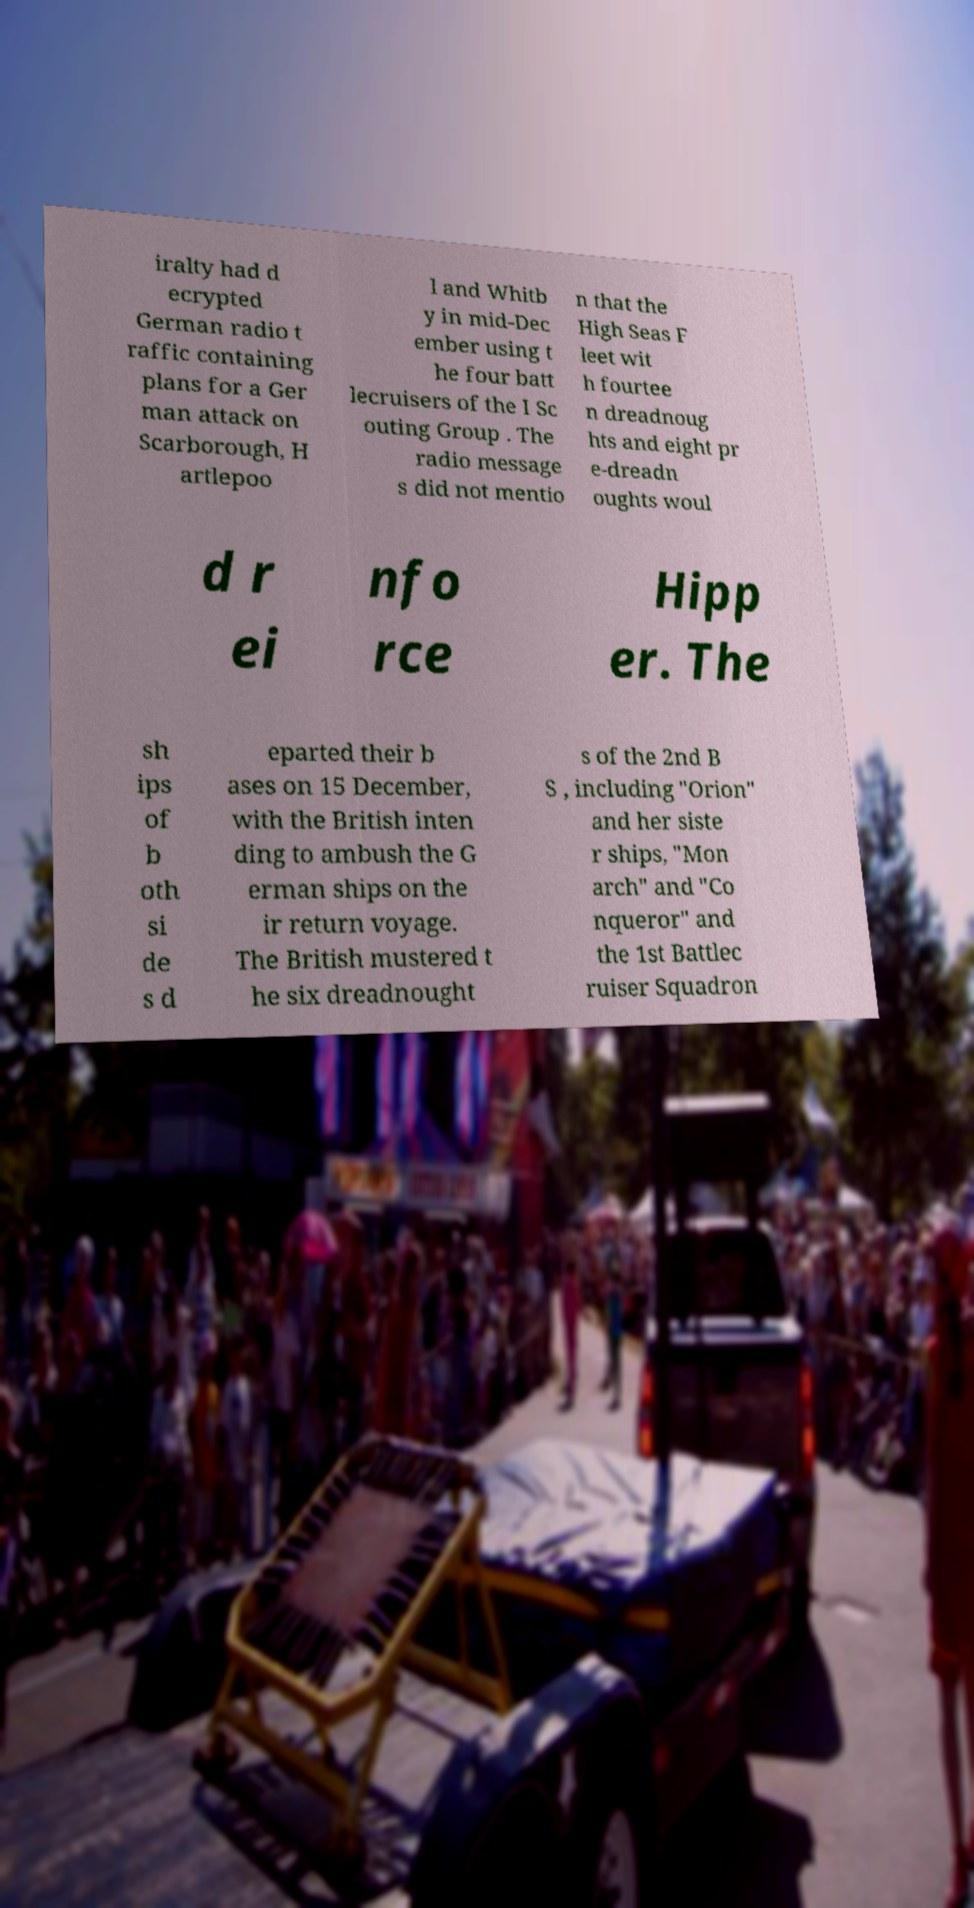There's text embedded in this image that I need extracted. Can you transcribe it verbatim? iralty had d ecrypted German radio t raffic containing plans for a Ger man attack on Scarborough, H artlepoo l and Whitb y in mid-Dec ember using t he four batt lecruisers of the I Sc outing Group . The radio message s did not mentio n that the High Seas F leet wit h fourtee n dreadnoug hts and eight pr e-dreadn oughts woul d r ei nfo rce Hipp er. The sh ips of b oth si de s d eparted their b ases on 15 December, with the British inten ding to ambush the G erman ships on the ir return voyage. The British mustered t he six dreadnought s of the 2nd B S , including "Orion" and her siste r ships, "Mon arch" and "Co nqueror" and the 1st Battlec ruiser Squadron 